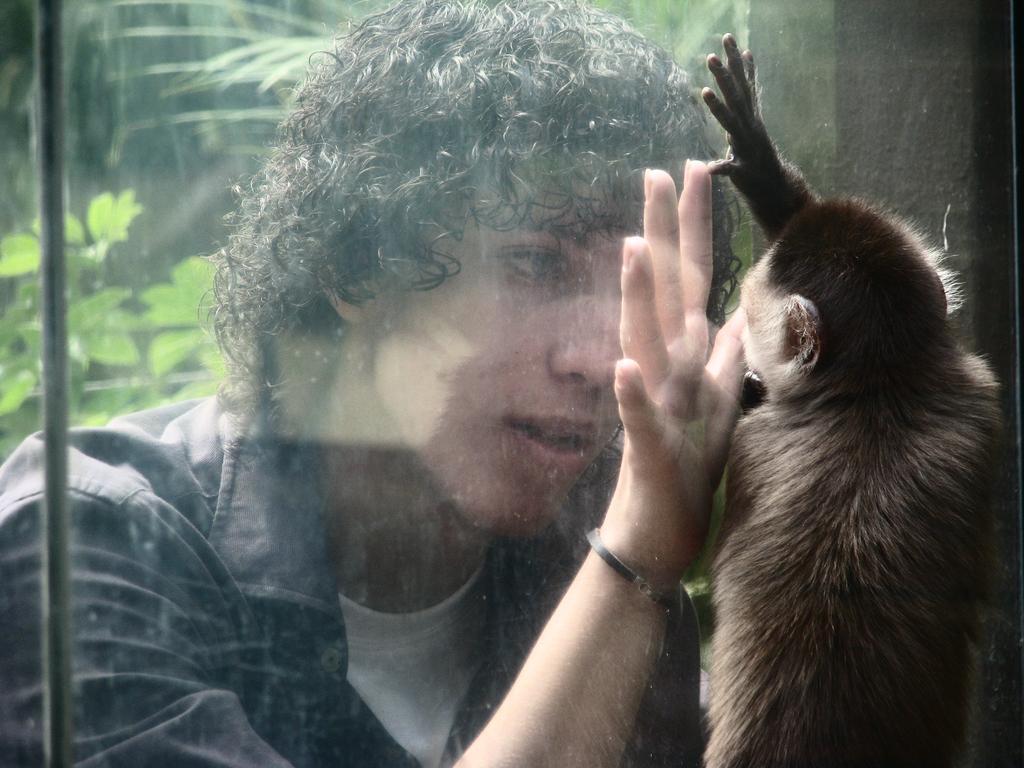Describe this image in one or two sentences. In this image I can see a monkey and a person. In the background I can see trees. 